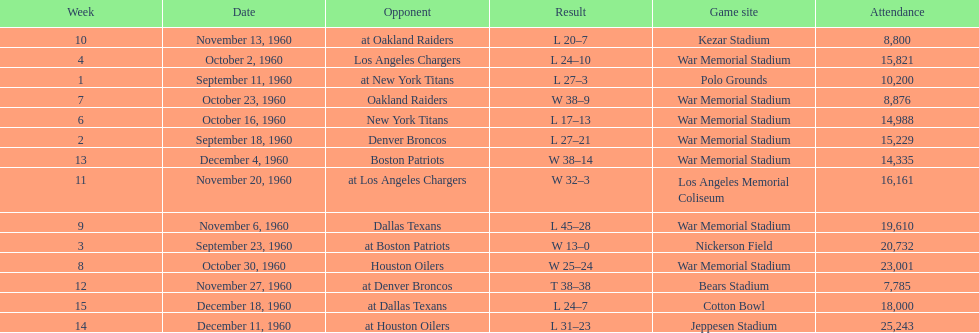Can you parse all the data within this table? {'header': ['Week', 'Date', 'Opponent', 'Result', 'Game site', 'Attendance'], 'rows': [['10', 'November 13, 1960', 'at Oakland Raiders', 'L 20–7', 'Kezar Stadium', '8,800'], ['4', 'October 2, 1960', 'Los Angeles Chargers', 'L 24–10', 'War Memorial Stadium', '15,821'], ['1', 'September 11, 1960', 'at New York Titans', 'L 27–3', 'Polo Grounds', '10,200'], ['7', 'October 23, 1960', 'Oakland Raiders', 'W 38–9', 'War Memorial Stadium', '8,876'], ['6', 'October 16, 1960', 'New York Titans', 'L 17–13', 'War Memorial Stadium', '14,988'], ['2', 'September 18, 1960', 'Denver Broncos', 'L 27–21', 'War Memorial Stadium', '15,229'], ['13', 'December 4, 1960', 'Boston Patriots', 'W 38–14', 'War Memorial Stadium', '14,335'], ['11', 'November 20, 1960', 'at Los Angeles Chargers', 'W 32–3', 'Los Angeles Memorial Coliseum', '16,161'], ['9', 'November 6, 1960', 'Dallas Texans', 'L 45–28', 'War Memorial Stadium', '19,610'], ['3', 'September 23, 1960', 'at Boston Patriots', 'W 13–0', 'Nickerson Field', '20,732'], ['8', 'October 30, 1960', 'Houston Oilers', 'W 25–24', 'War Memorial Stadium', '23,001'], ['12', 'November 27, 1960', 'at Denver Broncos', 'T 38–38', 'Bears Stadium', '7,785'], ['15', 'December 18, 1960', 'at Dallas Texans', 'L 24–7', 'Cotton Bowl', '18,000'], ['14', 'December 11, 1960', 'at Houston Oilers', 'L 31–23', 'Jeppesen Stadium', '25,243']]} Which date had the highest attendance? December 11, 1960. 